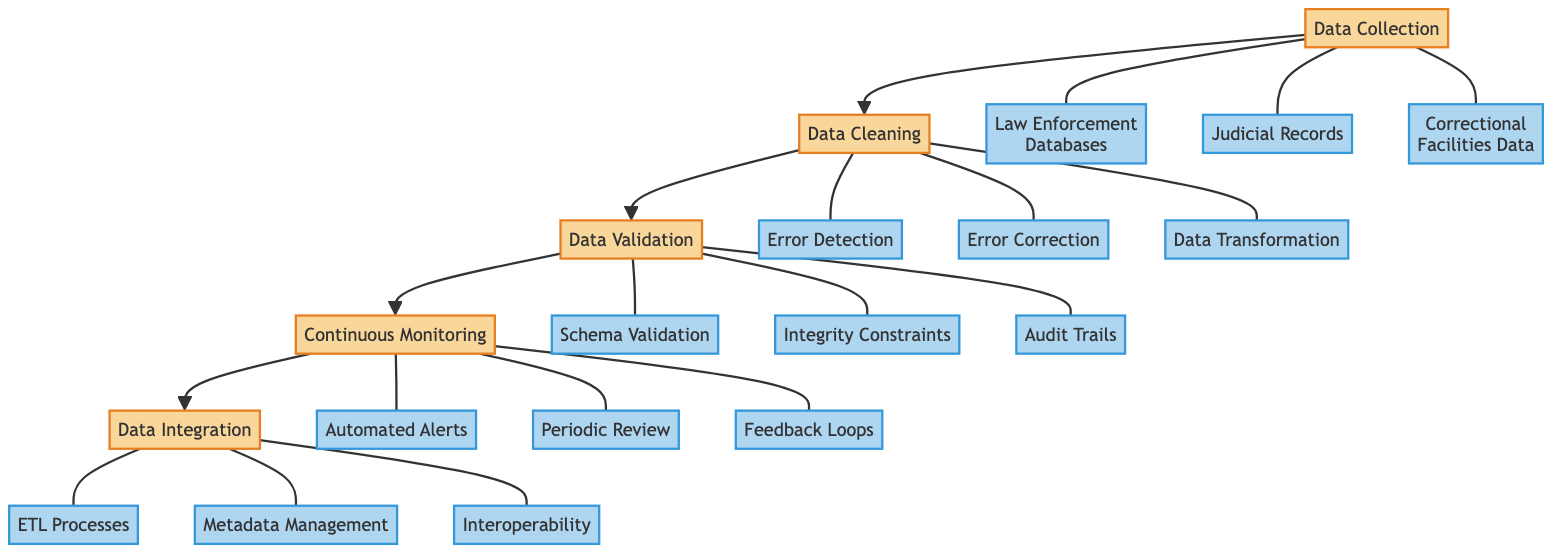What is the first node in the diagram? The first node in the diagram is "Data Collection", which denotes the initial step in the process of data quality monitoring.
Answer: Data Collection How many data cleaning components are presented in the diagram? The diagram lists three components under the "Data Cleaning" node—Error Detection, Error Correction, and Data Transformation. Counting these gives a total of three components.
Answer: 3 Which component follows "Data Cleaning" in the flow? After "Data Cleaning," the next component in the flow of the diagram is "Data Validation," indicating the sequence of processes to be followed.
Answer: Data Validation What methods are used in Error Detection? The methods used in Error Detection included in the diagram are "Missing Value Identification," "Duplicate Record Detection," and "Outlier Detection."
Answer: Missing Value Identification, Duplicate Record Detection, Outlier Detection What is the final component in the workflow? The final component in the workflow of the diagram is "Data Integration," which indicates that all previous processes lead to the unification of data.
Answer: Data Integration How many methods are identified under Integrity Constraints? The diagram shows three methods under Integrity Constraints: "Foreign Key Constraints," "Unique Key Constraints," and "Referential Integrity." This indicates the established methods for ensuring data integrity.
Answer: 3 What is the purpose of Continuous Monitoring? Continuous Monitoring serves as an ongoing process to maintain data quality, ensuring the datasets remain accurate and reliable over time.
Answer: Ongoing process Which monitoring method includes "Monthly Data Audits"? The method that includes "Monthly Data Audits" falls under "Periodic Review," which is a part of the Continuous Monitoring component of the diagram.
Answer: Periodic Review What is an example of a method under Feedback Loops? An example of a method listed under Feedback Loops in the diagram is "Error Reporting Mechanisms," which highlights a mechanism to gather information on any errors present in the datasets.
Answer: Error Reporting Mechanisms 